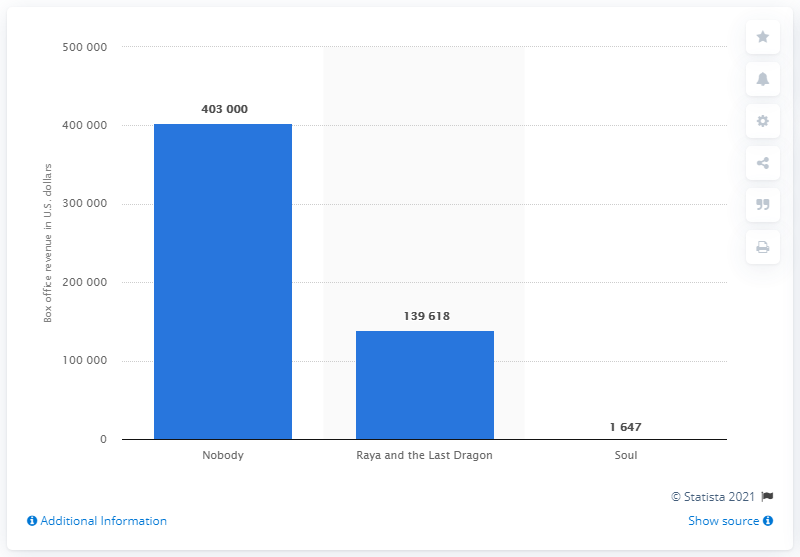Point out several critical features in this image. The movie "Soul" ranked third on the weekend box office in Taiwan. 